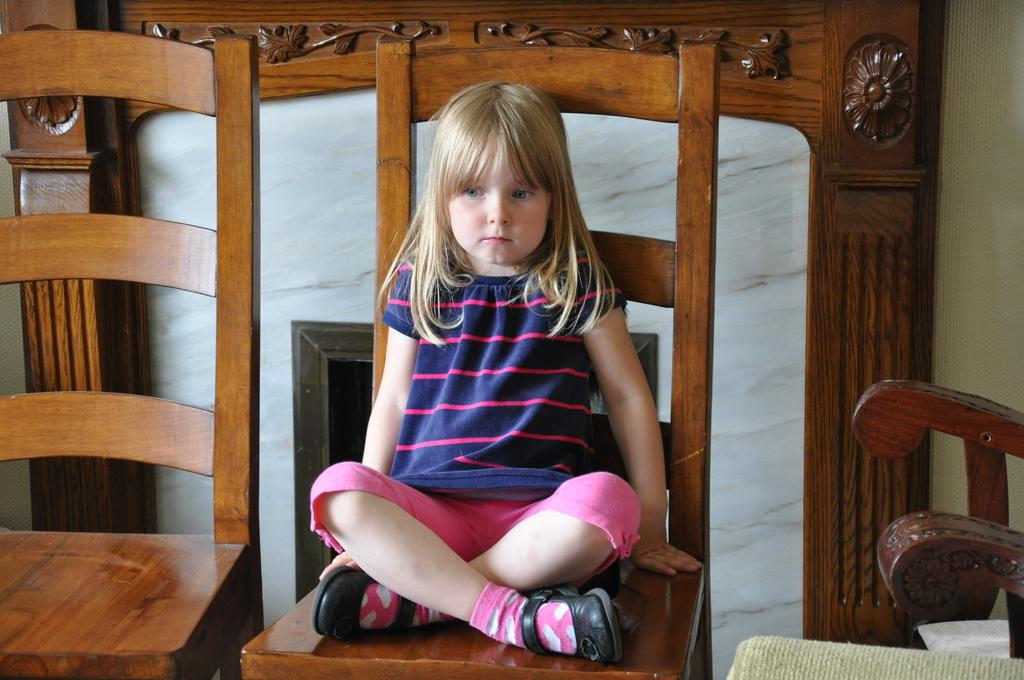Who is the main subject in the image? There is a small girl in the image. What is the girl doing in the image? The girl is sitting on a brown chair. Are there any other chairs visible in the image? Yes, there is an unoccupied chair beside the girl. What can be seen in the background of the image? There is a wooden slate in the background of the image, and marble is present on it. How many cakes are being served in the nest in the image? There are no cakes or nests present in the image. What type of cattle can be seen grazing near the wooden slate? There are no cattle visible in the image; it only features a small girl, chairs, and a wooden slate with marble. 